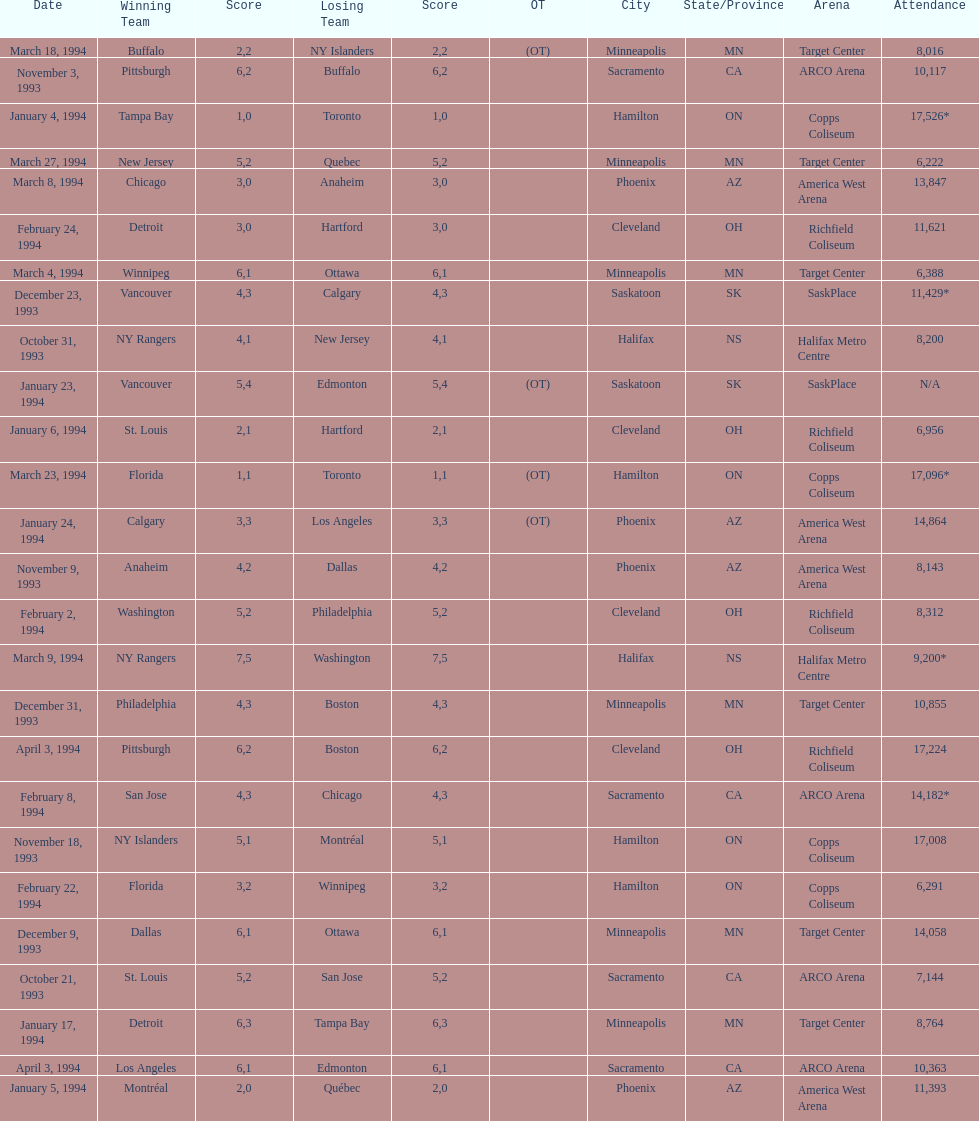Could you parse the entire table as a dict? {'header': ['Date', 'Winning Team', 'Score', 'Losing Team', 'Score', 'OT', 'City', 'State/Province', 'Arena', 'Attendance'], 'rows': [['March 18, 1994', 'Buffalo', '2', 'NY Islanders', '2', '(OT)', 'Minneapolis', 'MN', 'Target Center', '8,016'], ['November 3, 1993', 'Pittsburgh', '6', 'Buffalo', '2', '', 'Sacramento', 'CA', 'ARCO Arena', '10,117'], ['January 4, 1994', 'Tampa Bay', '1', 'Toronto', '0', '', 'Hamilton', 'ON', 'Copps Coliseum', '17,526*'], ['March 27, 1994', 'New Jersey', '5', 'Quebec', '2', '', 'Minneapolis', 'MN', 'Target Center', '6,222'], ['March 8, 1994', 'Chicago', '3', 'Anaheim', '0', '', 'Phoenix', 'AZ', 'America West Arena', '13,847'], ['February 24, 1994', 'Detroit', '3', 'Hartford', '0', '', 'Cleveland', 'OH', 'Richfield Coliseum', '11,621'], ['March 4, 1994', 'Winnipeg', '6', 'Ottawa', '1', '', 'Minneapolis', 'MN', 'Target Center', '6,388'], ['December 23, 1993', 'Vancouver', '4', 'Calgary', '3', '', 'Saskatoon', 'SK', 'SaskPlace', '11,429*'], ['October 31, 1993', 'NY Rangers', '4', 'New Jersey', '1', '', 'Halifax', 'NS', 'Halifax Metro Centre', '8,200'], ['January 23, 1994', 'Vancouver', '5', 'Edmonton', '4', '(OT)', 'Saskatoon', 'SK', 'SaskPlace', 'N/A'], ['January 6, 1994', 'St. Louis', '2', 'Hartford', '1', '', 'Cleveland', 'OH', 'Richfield Coliseum', '6,956'], ['March 23, 1994', 'Florida', '1', 'Toronto', '1', '(OT)', 'Hamilton', 'ON', 'Copps Coliseum', '17,096*'], ['January 24, 1994', 'Calgary', '3', 'Los Angeles', '3', '(OT)', 'Phoenix', 'AZ', 'America West Arena', '14,864'], ['November 9, 1993', 'Anaheim', '4', 'Dallas', '2', '', 'Phoenix', 'AZ', 'America West Arena', '8,143'], ['February 2, 1994', 'Washington', '5', 'Philadelphia', '2', '', 'Cleveland', 'OH', 'Richfield Coliseum', '8,312'], ['March 9, 1994', 'NY Rangers', '7', 'Washington', '5', '', 'Halifax', 'NS', 'Halifax Metro Centre', '9,200*'], ['December 31, 1993', 'Philadelphia', '4', 'Boston', '3', '', 'Minneapolis', 'MN', 'Target Center', '10,855'], ['April 3, 1994', 'Pittsburgh', '6', 'Boston', '2', '', 'Cleveland', 'OH', 'Richfield Coliseum', '17,224'], ['February 8, 1994', 'San Jose', '4', 'Chicago', '3', '', 'Sacramento', 'CA', 'ARCO Arena', '14,182*'], ['November 18, 1993', 'NY Islanders', '5', 'Montréal', '1', '', 'Hamilton', 'ON', 'Copps Coliseum', '17,008'], ['February 22, 1994', 'Florida', '3', 'Winnipeg', '2', '', 'Hamilton', 'ON', 'Copps Coliseum', '6,291'], ['December 9, 1993', 'Dallas', '6', 'Ottawa', '1', '', 'Minneapolis', 'MN', 'Target Center', '14,058'], ['October 21, 1993', 'St. Louis', '5', 'San Jose', '2', '', 'Sacramento', 'CA', 'ARCO Arena', '7,144'], ['January 17, 1994', 'Detroit', '6', 'Tampa Bay', '3', '', 'Minneapolis', 'MN', 'Target Center', '8,764'], ['April 3, 1994', 'Los Angeles', '6', 'Edmonton', '1', '', 'Sacramento', 'CA', 'ARCO Arena', '10,363'], ['January 5, 1994', 'Montréal', '2', 'Québec', '0', '', 'Phoenix', 'AZ', 'America West Arena', '11,393']]} How many neutral site games resulted in overtime (ot)? 4. 